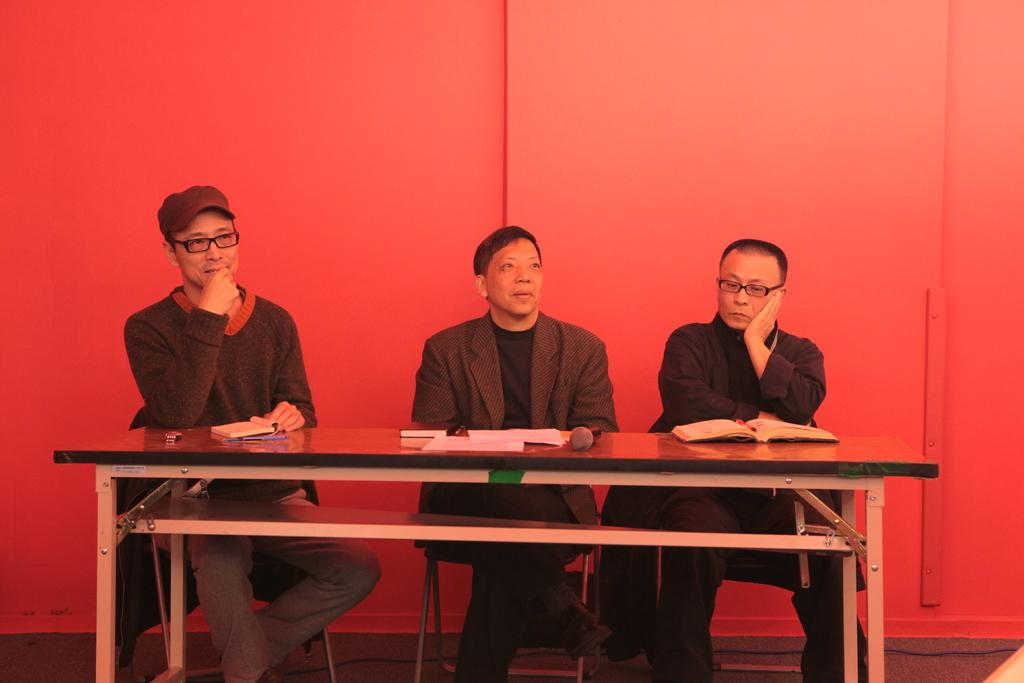How many people are in the image? There are three men in the image. What are the men doing in the image? The men are sitting in chairs. Where are the chairs located in the image? The chairs are at a table. What type of fuel is being used by the orange in the image? There is no orange present in the image, and therefore no fuel can be associated with it. 